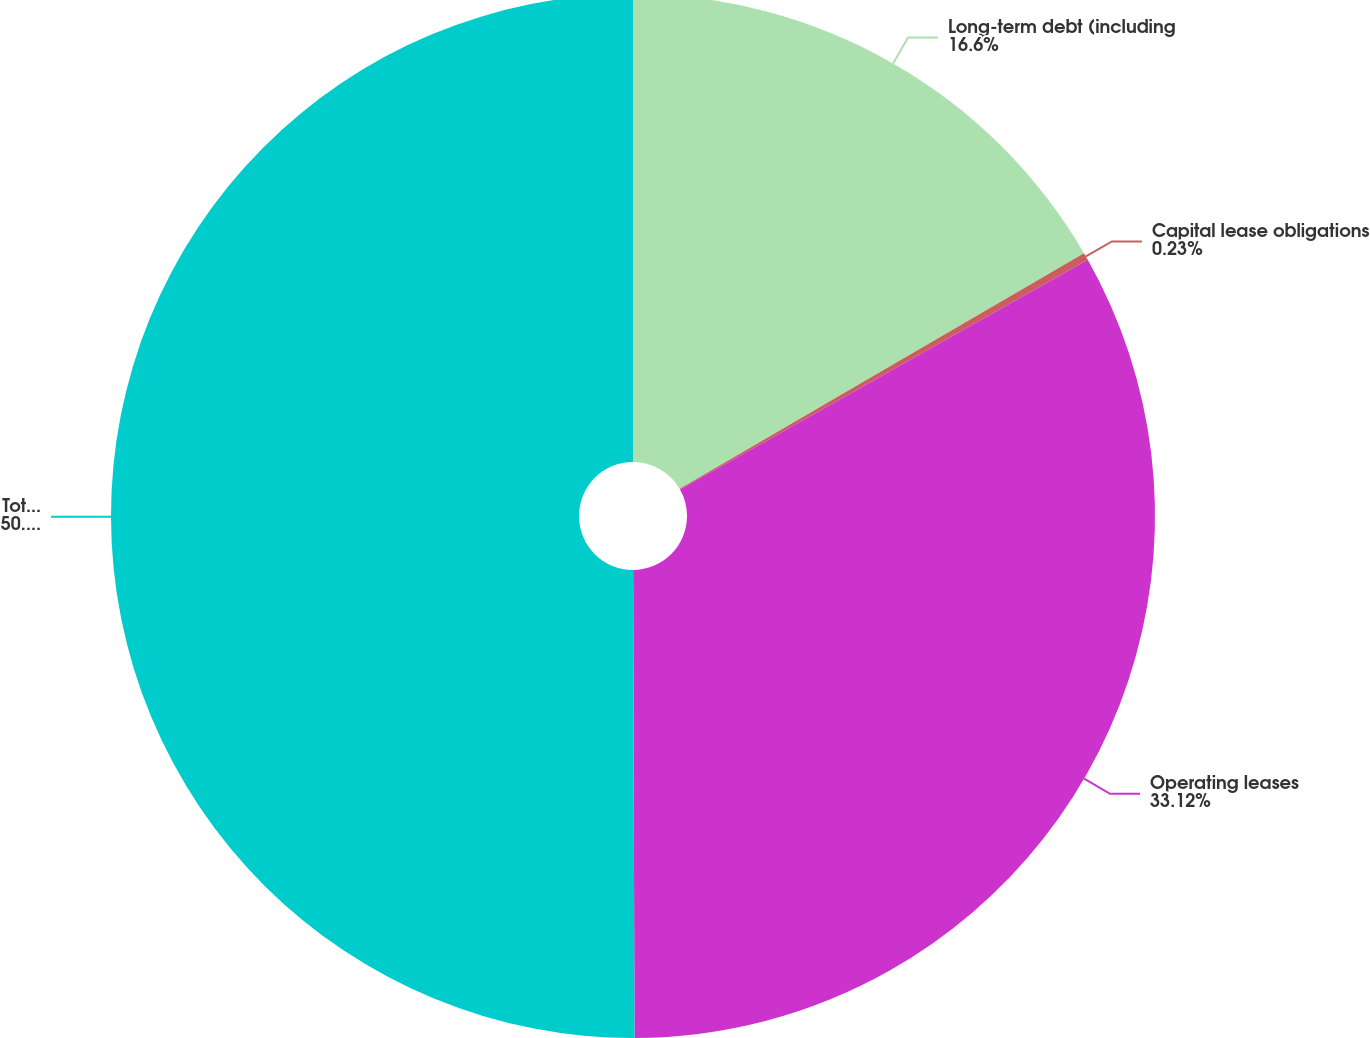Convert chart. <chart><loc_0><loc_0><loc_500><loc_500><pie_chart><fcel>Long-term debt (including<fcel>Capital lease obligations<fcel>Operating leases<fcel>Total contractual cash<nl><fcel>16.6%<fcel>0.23%<fcel>33.12%<fcel>50.04%<nl></chart> 